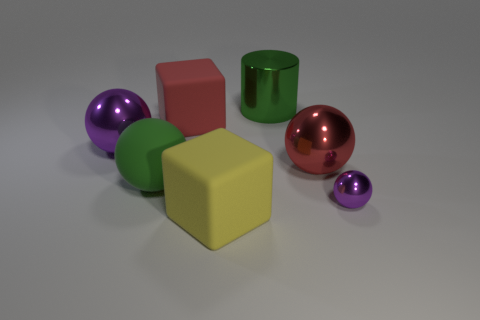Subtract all small metallic spheres. How many spheres are left? 3 Subtract all purple balls. How many balls are left? 2 Subtract 1 cubes. How many cubes are left? 1 Subtract all balls. How many objects are left? 3 Subtract all green cylinders. How many purple balls are left? 2 Add 2 green things. How many objects exist? 9 Subtract 0 purple blocks. How many objects are left? 7 Subtract all green cubes. Subtract all purple balls. How many cubes are left? 2 Subtract all large blue shiny balls. Subtract all green cylinders. How many objects are left? 6 Add 3 green rubber balls. How many green rubber balls are left? 4 